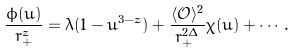<formula> <loc_0><loc_0><loc_500><loc_500>\frac { \phi ( u ) } { r _ { + } ^ { z } } = \lambda ( 1 - u ^ { 3 - z } ) + \frac { \langle \mathcal { O } \rangle ^ { 2 } } { r ^ { 2 \Delta } _ { + } } \chi ( u ) + \cdots .</formula> 